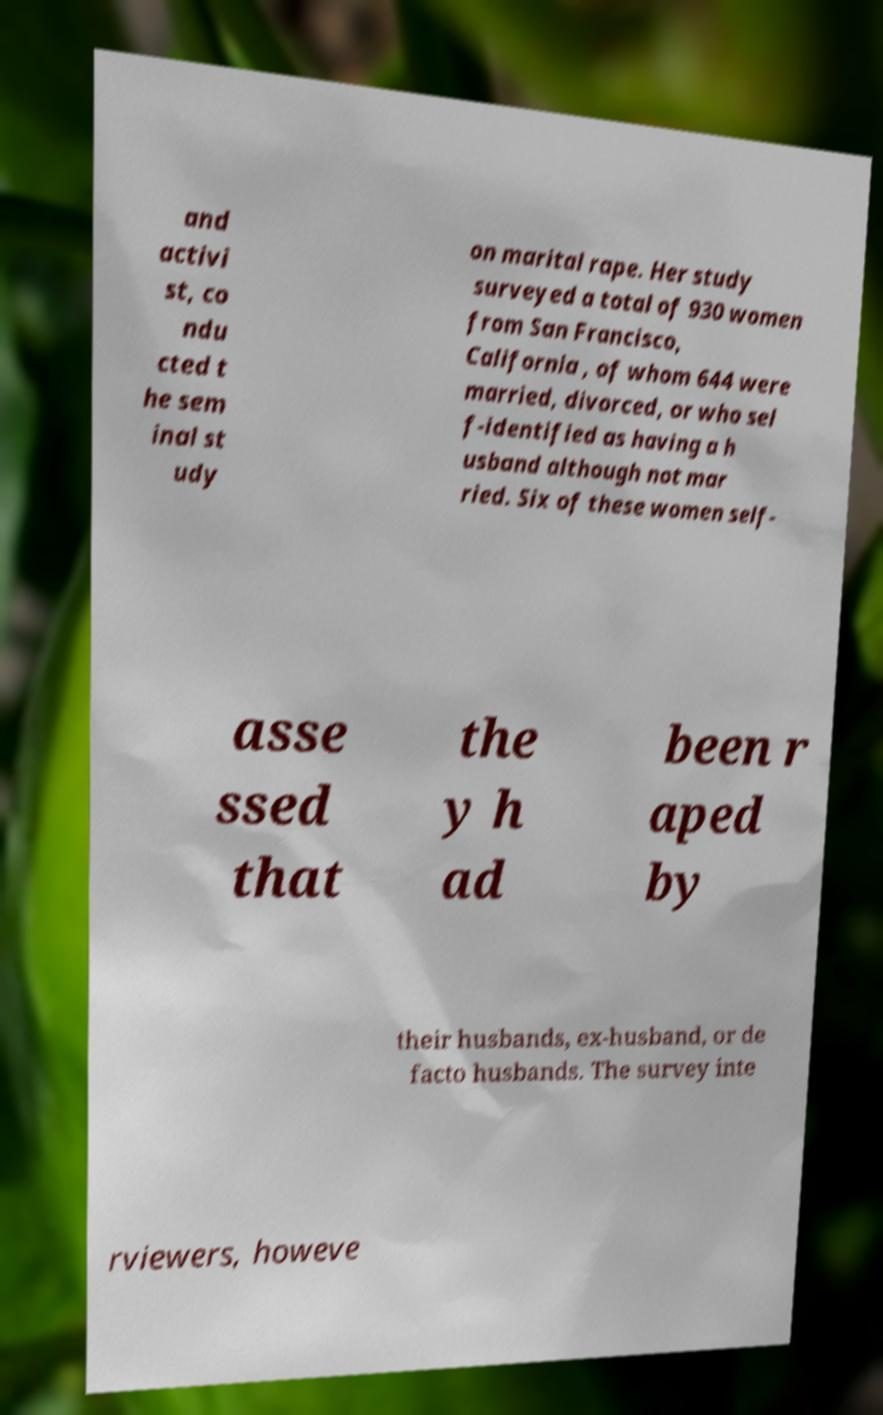Please identify and transcribe the text found in this image. and activi st, co ndu cted t he sem inal st udy on marital rape. Her study surveyed a total of 930 women from San Francisco, California , of whom 644 were married, divorced, or who sel f-identified as having a h usband although not mar ried. Six of these women self- asse ssed that the y h ad been r aped by their husbands, ex-husband, or de facto husbands. The survey inte rviewers, howeve 